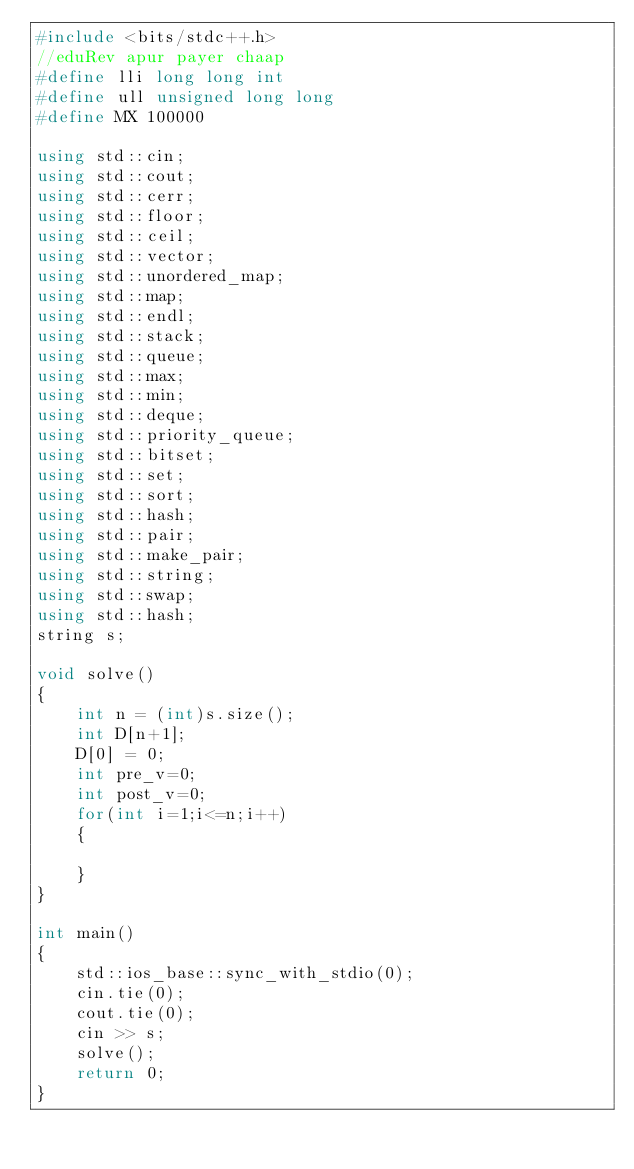<code> <loc_0><loc_0><loc_500><loc_500><_C++_>#include <bits/stdc++.h>
//eduRev apur payer chaap
#define lli long long int
#define ull unsigned long long
#define MX 100000

using std::cin;
using std::cout;
using std::cerr;
using std::floor;
using std::ceil;
using std::vector;
using std::unordered_map;
using std::map;
using std::endl;
using std::stack;
using std::queue;
using std::max;
using std::min;
using std::deque;
using std::priority_queue;
using std::bitset;
using std::set;
using std::sort;
using std::hash;
using std::pair;
using std::make_pair;
using std::string;
using std::swap;
using std::hash;
string s;

void solve()
{
    int n = (int)s.size();
    int D[n+1];
    D[0] = 0;
    int pre_v=0;
    int post_v=0;
    for(int i=1;i<=n;i++)
    {

    }
}

int main()
{
    std::ios_base::sync_with_stdio(0);
    cin.tie(0);
    cout.tie(0);
    cin >> s;
    solve();
    return 0;
}
</code> 